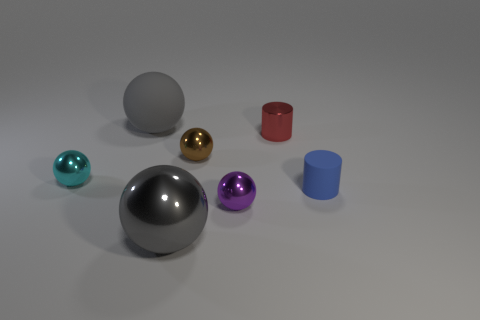Are there any gray shiny objects of the same size as the gray matte ball?
Your answer should be compact. Yes. What color is the tiny thing that is behind the tiny brown shiny thing?
Make the answer very short. Red. The metallic thing that is both behind the blue thing and to the right of the tiny brown metallic ball has what shape?
Provide a short and direct response. Cylinder. How many matte things are the same shape as the cyan shiny object?
Keep it short and to the point. 1. How many brown matte things are there?
Provide a short and direct response. 0. There is a thing that is on the right side of the tiny purple metal ball and to the left of the matte cylinder; what size is it?
Provide a short and direct response. Small. The cyan metallic thing that is the same size as the purple metal ball is what shape?
Offer a very short reply. Sphere. There is a metallic object left of the matte ball; are there any tiny cyan things that are to the left of it?
Provide a succinct answer. No. What is the color of the other large object that is the same shape as the large matte thing?
Make the answer very short. Gray. Does the big ball that is behind the tiny red shiny thing have the same color as the large shiny object?
Ensure brevity in your answer.  Yes. 